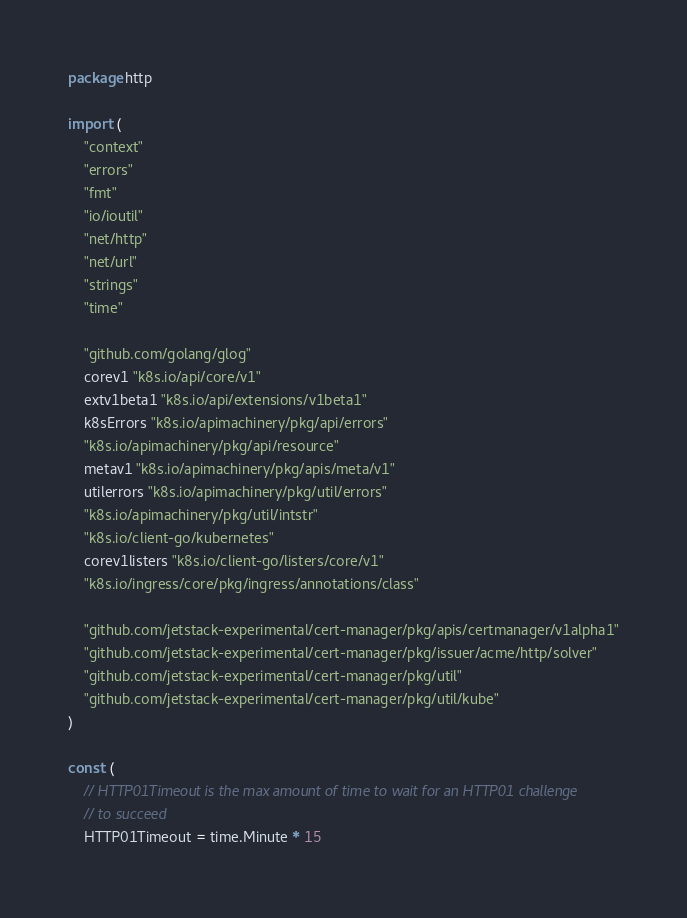Convert code to text. <code><loc_0><loc_0><loc_500><loc_500><_Go_>package http

import (
	"context"
	"errors"
	"fmt"
	"io/ioutil"
	"net/http"
	"net/url"
	"strings"
	"time"

	"github.com/golang/glog"
	corev1 "k8s.io/api/core/v1"
	extv1beta1 "k8s.io/api/extensions/v1beta1"
	k8sErrors "k8s.io/apimachinery/pkg/api/errors"
	"k8s.io/apimachinery/pkg/api/resource"
	metav1 "k8s.io/apimachinery/pkg/apis/meta/v1"
	utilerrors "k8s.io/apimachinery/pkg/util/errors"
	"k8s.io/apimachinery/pkg/util/intstr"
	"k8s.io/client-go/kubernetes"
	corev1listers "k8s.io/client-go/listers/core/v1"
	"k8s.io/ingress/core/pkg/ingress/annotations/class"

	"github.com/jetstack-experimental/cert-manager/pkg/apis/certmanager/v1alpha1"
	"github.com/jetstack-experimental/cert-manager/pkg/issuer/acme/http/solver"
	"github.com/jetstack-experimental/cert-manager/pkg/util"
	"github.com/jetstack-experimental/cert-manager/pkg/util/kube"
)

const (
	// HTTP01Timeout is the max amount of time to wait for an HTTP01 challenge
	// to succeed
	HTTP01Timeout = time.Minute * 15</code> 